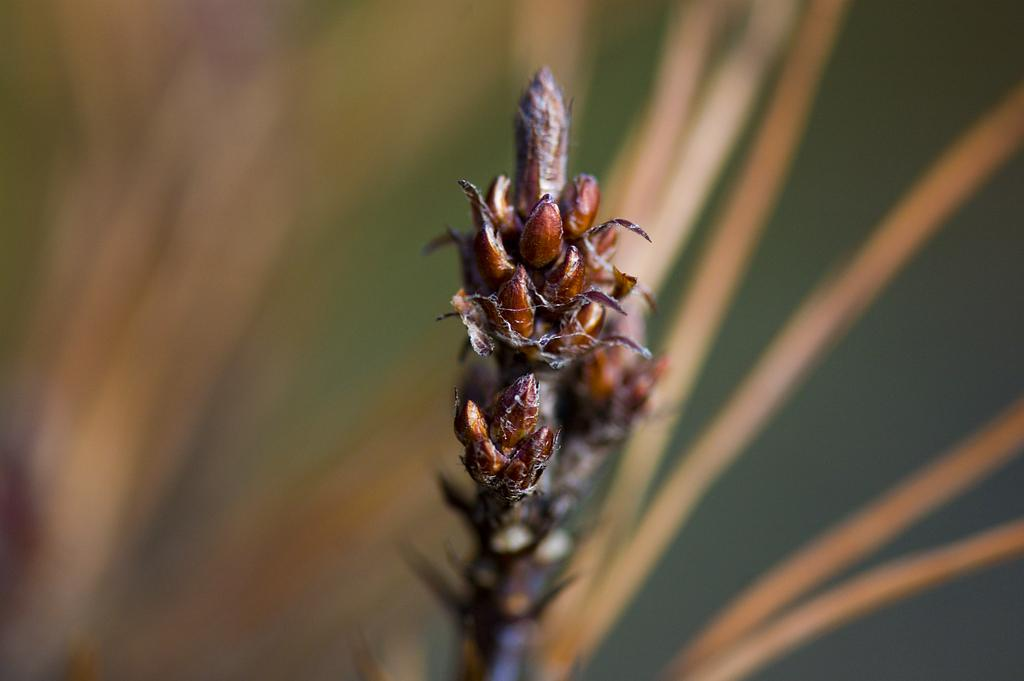What is the main subject of the image? The main subject of the image is a bud of a plant. Can you describe the background of the image? The background of the image is blurred. What type of scene is depicted in the background of the image? There is no scene visible in the background of the image, as it is blurred. What is the difference between a bud and a twig in the image? There is no twig present in the image; it only contains a bud of a plant. 